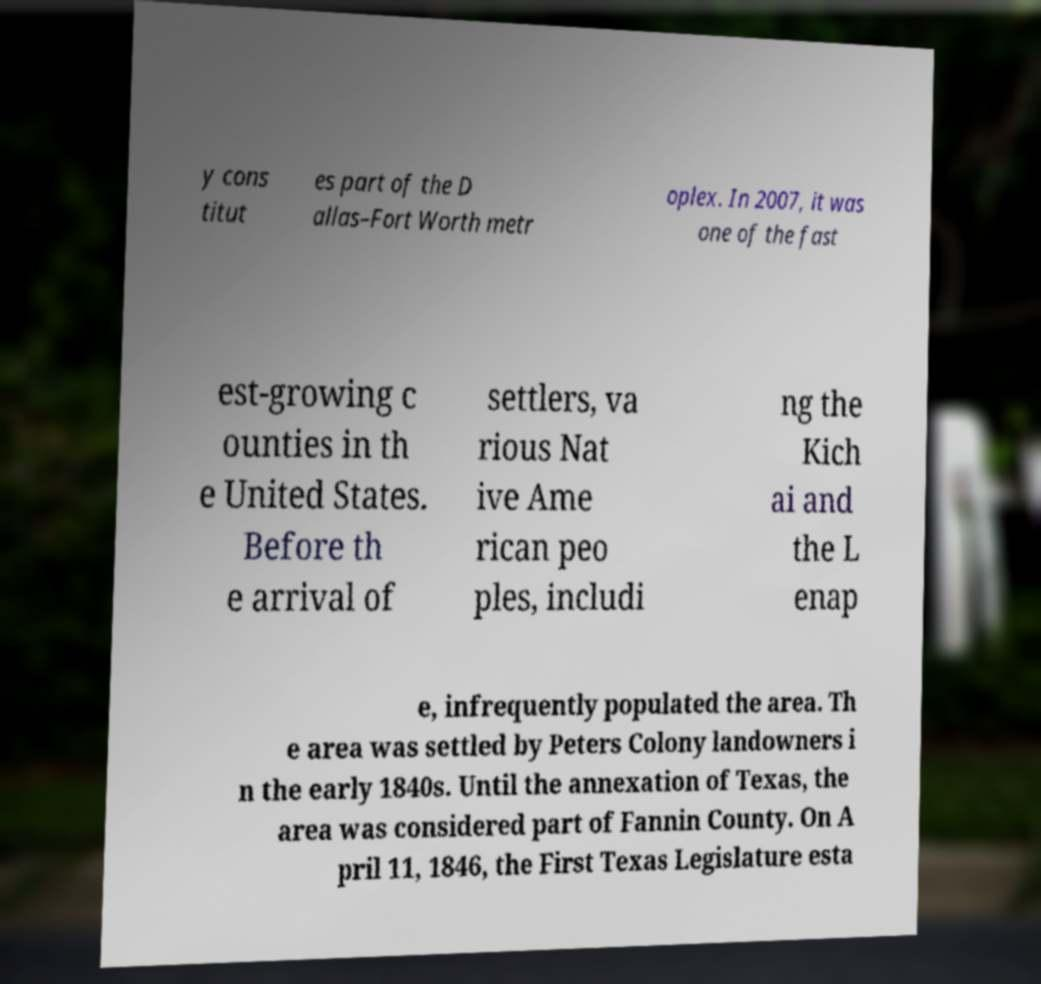What messages or text are displayed in this image? I need them in a readable, typed format. y cons titut es part of the D allas–Fort Worth metr oplex. In 2007, it was one of the fast est-growing c ounties in th e United States. Before th e arrival of settlers, va rious Nat ive Ame rican peo ples, includi ng the Kich ai and the L enap e, infrequently populated the area. Th e area was settled by Peters Colony landowners i n the early 1840s. Until the annexation of Texas, the area was considered part of Fannin County. On A pril 11, 1846, the First Texas Legislature esta 